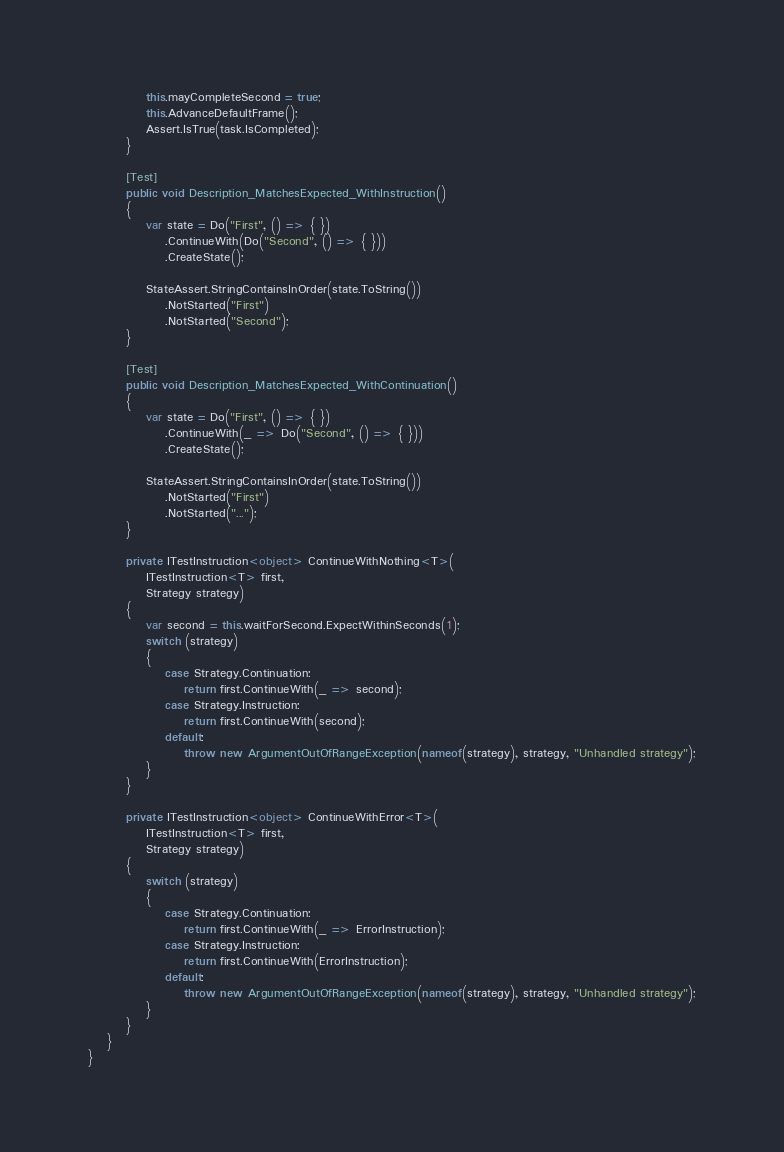<code> <loc_0><loc_0><loc_500><loc_500><_C#_>
			this.mayCompleteSecond = true;
			this.AdvanceDefaultFrame();
			Assert.IsTrue(task.IsCompleted);
		}

		[Test]
		public void Description_MatchesExpected_WithInstruction()
		{
			var state = Do("First", () => { })
				.ContinueWith(Do("Second", () => { }))
				.CreateState();

			StateAssert.StringContainsInOrder(state.ToString())
				.NotStarted("First")
				.NotStarted("Second");
		}

		[Test]
		public void Description_MatchesExpected_WithContinuation()
		{
			var state = Do("First", () => { })
				.ContinueWith(_ => Do("Second", () => { }))
				.CreateState();

			StateAssert.StringContainsInOrder(state.ToString())
				.NotStarted("First")
				.NotStarted("...");
		}

		private ITestInstruction<object> ContinueWithNothing<T>(
			ITestInstruction<T> first,
			Strategy strategy)
		{
			var second = this.waitForSecond.ExpectWithinSeconds(1);
			switch (strategy)
			{
				case Strategy.Continuation:
					return first.ContinueWith(_ => second);
				case Strategy.Instruction:
					return first.ContinueWith(second);
				default:
					throw new ArgumentOutOfRangeException(nameof(strategy), strategy, "Unhandled strategy");
			}
		}

		private ITestInstruction<object> ContinueWithError<T>(
			ITestInstruction<T> first,
			Strategy strategy)
		{
			switch (strategy)
			{
				case Strategy.Continuation:
					return first.ContinueWith(_ => ErrorInstruction);
				case Strategy.Instruction:
					return first.ContinueWith(ErrorInstruction);
				default:
					throw new ArgumentOutOfRangeException(nameof(strategy), strategy, "Unhandled strategy");
			}
		}
	}
}
</code> 